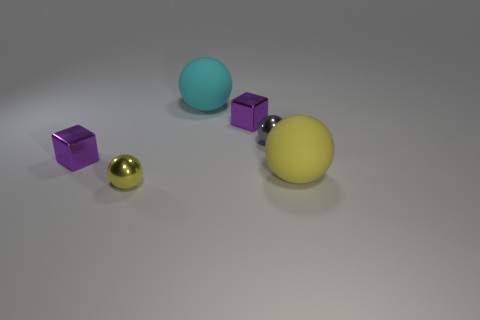There is a big yellow thing that is the same shape as the big cyan thing; what is its material?
Offer a very short reply. Rubber. What number of rubber things are green objects or gray balls?
Your answer should be very brief. 0. Are the big thing to the left of the yellow matte ball and the big thing that is to the right of the big cyan sphere made of the same material?
Offer a terse response. Yes. Are there any cubes?
Provide a short and direct response. Yes. Does the small gray object that is behind the tiny yellow ball have the same shape as the rubber object in front of the big cyan rubber object?
Offer a terse response. Yes. Are there any other balls that have the same material as the big cyan ball?
Your answer should be compact. Yes. Is the yellow sphere that is behind the yellow metallic object made of the same material as the cyan ball?
Your answer should be compact. Yes. Are there more purple shiny objects in front of the tiny yellow sphere than balls that are behind the large cyan rubber ball?
Ensure brevity in your answer.  No. The metal sphere that is the same size as the yellow metal object is what color?
Ensure brevity in your answer.  Gray. Is the color of the small block that is left of the cyan sphere the same as the large thing that is on the right side of the cyan matte object?
Keep it short and to the point. No. 